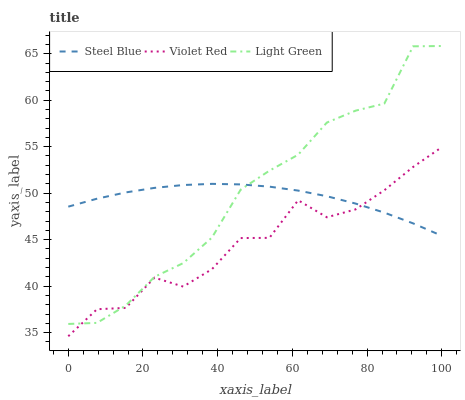Does Steel Blue have the minimum area under the curve?
Answer yes or no. No. Does Steel Blue have the maximum area under the curve?
Answer yes or no. No. Is Light Green the smoothest?
Answer yes or no. No. Is Light Green the roughest?
Answer yes or no. No. Does Light Green have the lowest value?
Answer yes or no. No. Does Steel Blue have the highest value?
Answer yes or no. No. 